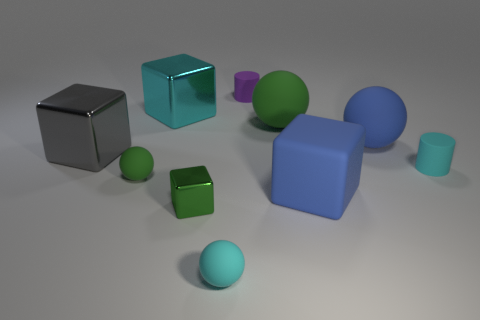Is the cylinder behind the cyan metallic object made of the same material as the large block that is to the left of the cyan shiny cube?
Provide a short and direct response. No. There is a tiny cyan rubber object left of the small purple cylinder; what is its shape?
Offer a very short reply. Sphere. What size is the blue thing that is the same shape as the big gray thing?
Give a very brief answer. Large. Do the matte cube and the small metal thing have the same color?
Provide a succinct answer. No. Is there any other thing that has the same shape as the tiny green metallic object?
Offer a terse response. Yes. There is a small cyan rubber cylinder in front of the large cyan metal block; is there a small object on the left side of it?
Provide a succinct answer. Yes. What is the color of the other big rubber thing that is the same shape as the large gray object?
Ensure brevity in your answer.  Blue. What number of large metal cubes have the same color as the tiny metallic object?
Your response must be concise. 0. There is a matte cylinder right of the big blue thing that is behind the cyan object on the right side of the purple cylinder; what is its color?
Your response must be concise. Cyan. Is the material of the large cyan cube the same as the purple thing?
Provide a succinct answer. No. 